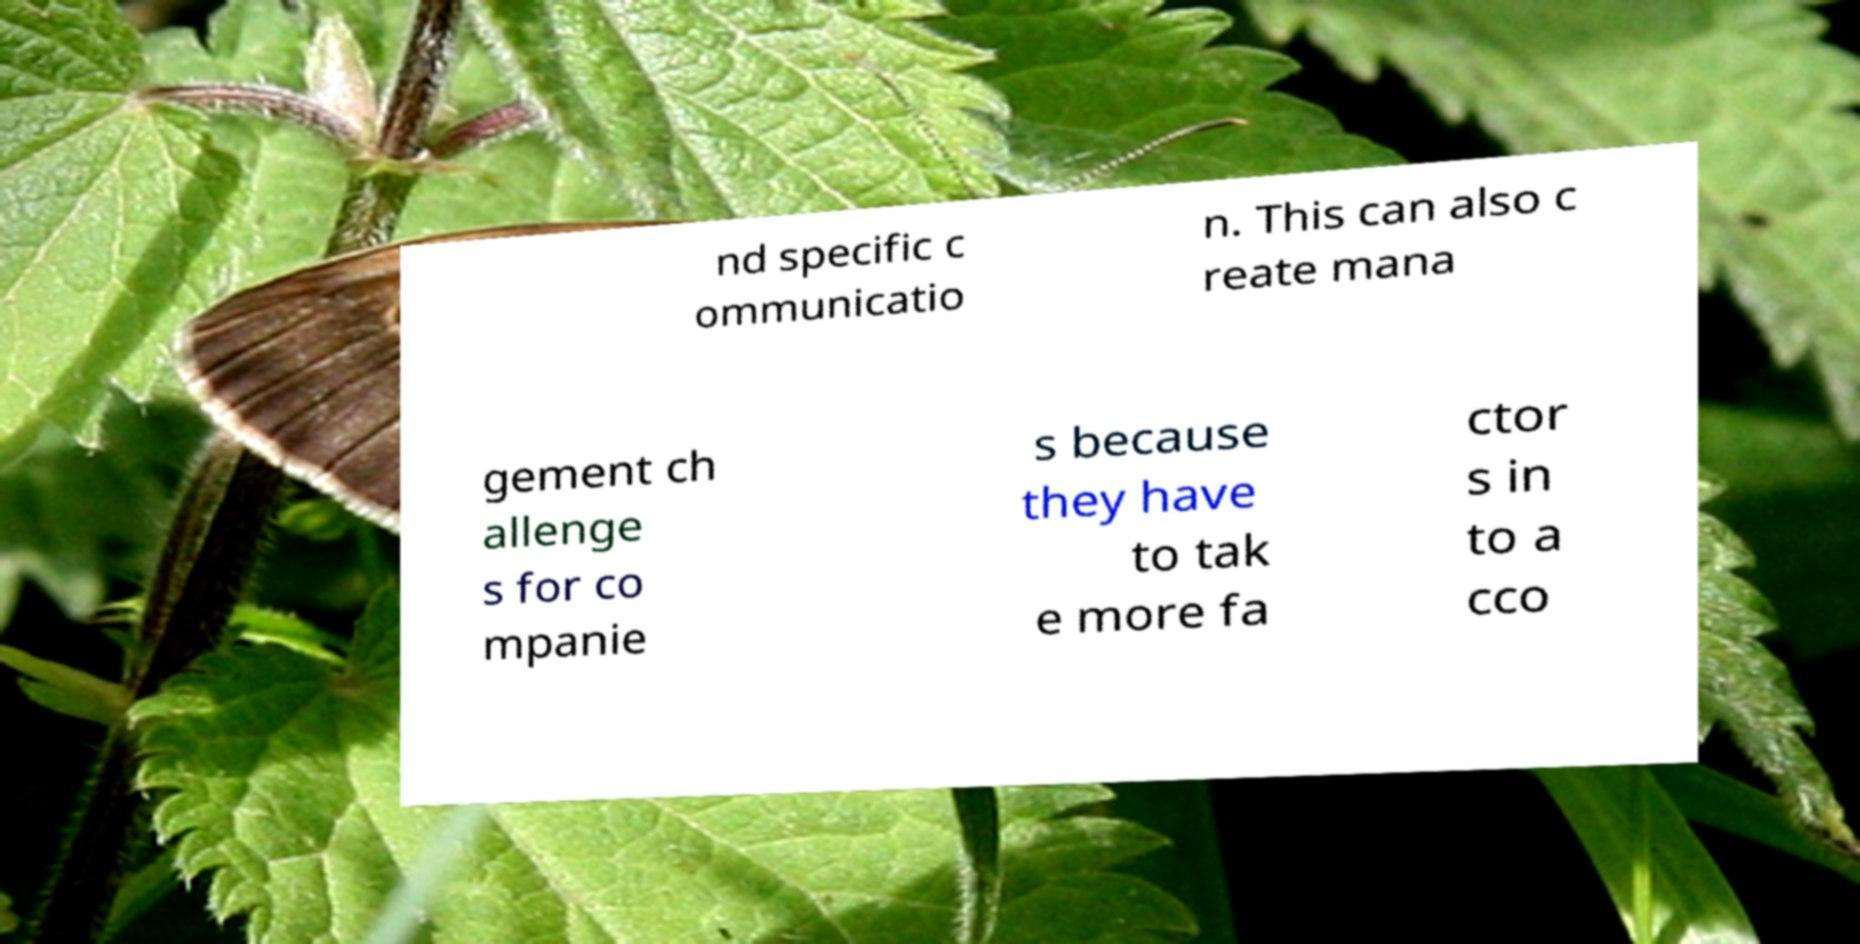Could you assist in decoding the text presented in this image and type it out clearly? nd specific c ommunicatio n. This can also c reate mana gement ch allenge s for co mpanie s because they have to tak e more fa ctor s in to a cco 